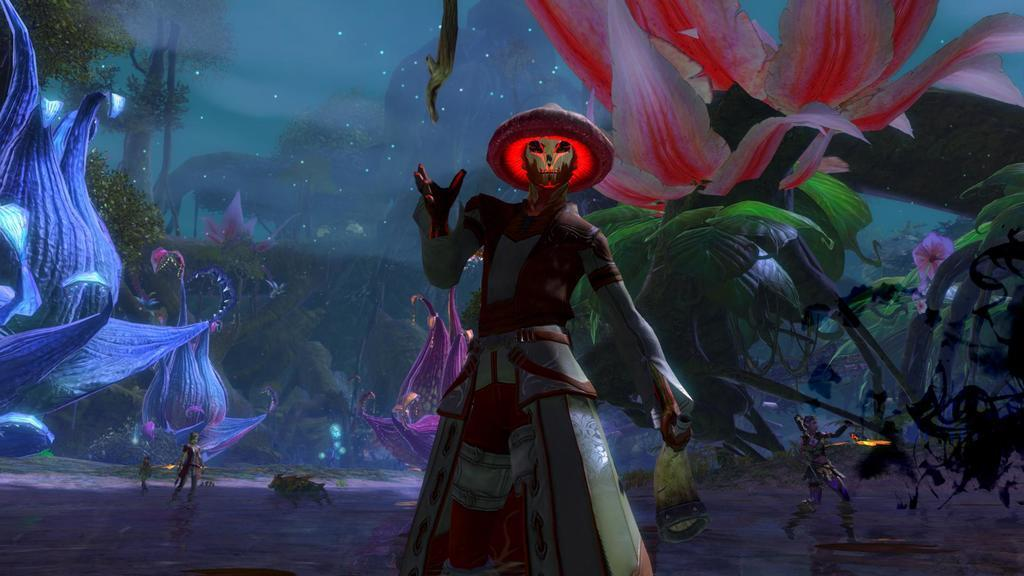What is happening in the image? There are people standing in the image. What are the people wearing? The people are wearing clothes. Can you describe any specific clothing item in the image? One person is wearing a hat. What type of natural elements can be seen in the image? There are trees, flowers, and leaves in the image. What type of library can be seen in the image? There is no library present in the image. What is the texture of the flowers in the image? The provided facts do not mention the texture of the flowers, so it cannot be determined from the image. 